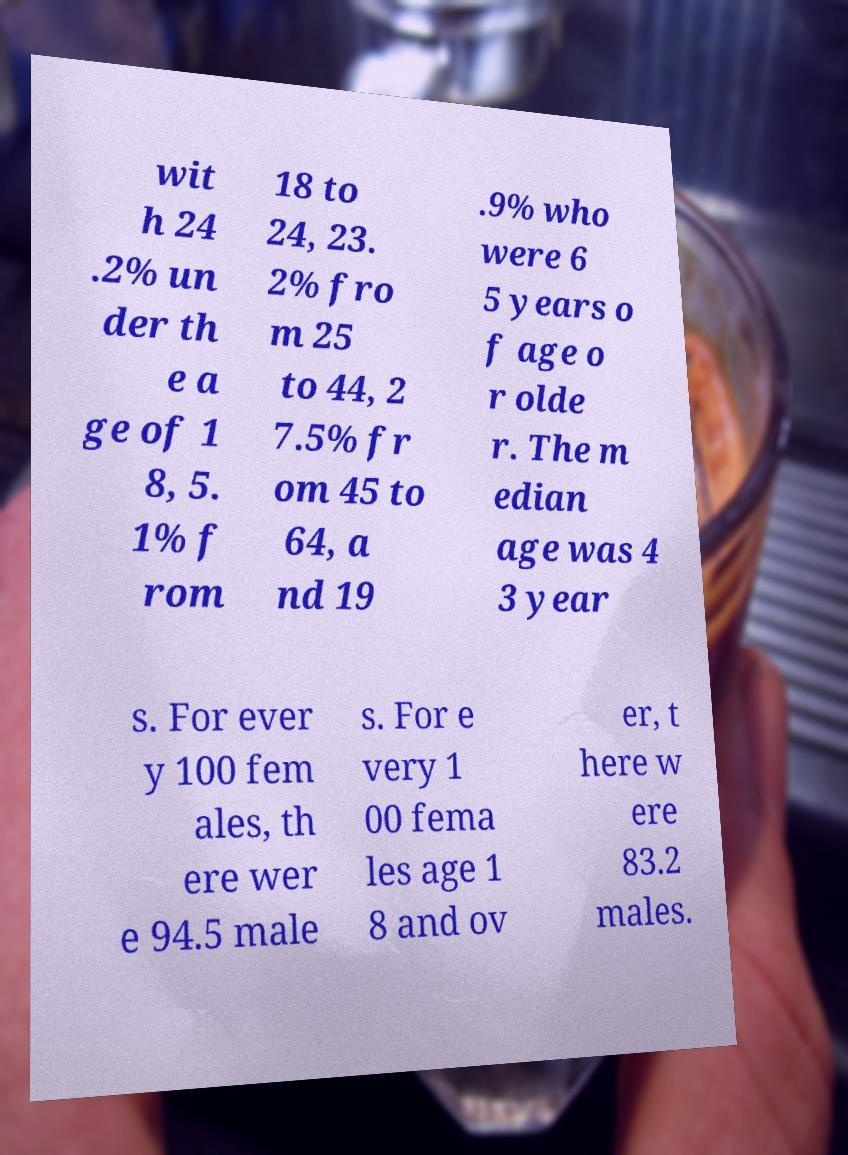Could you extract and type out the text from this image? wit h 24 .2% un der th e a ge of 1 8, 5. 1% f rom 18 to 24, 23. 2% fro m 25 to 44, 2 7.5% fr om 45 to 64, a nd 19 .9% who were 6 5 years o f age o r olde r. The m edian age was 4 3 year s. For ever y 100 fem ales, th ere wer e 94.5 male s. For e very 1 00 fema les age 1 8 and ov er, t here w ere 83.2 males. 